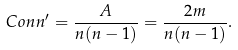<formula> <loc_0><loc_0><loc_500><loc_500>C o n n ^ { \prime } = \frac { A } { n ( n - 1 ) } = \frac { 2 m } { n ( n - 1 ) } .</formula> 